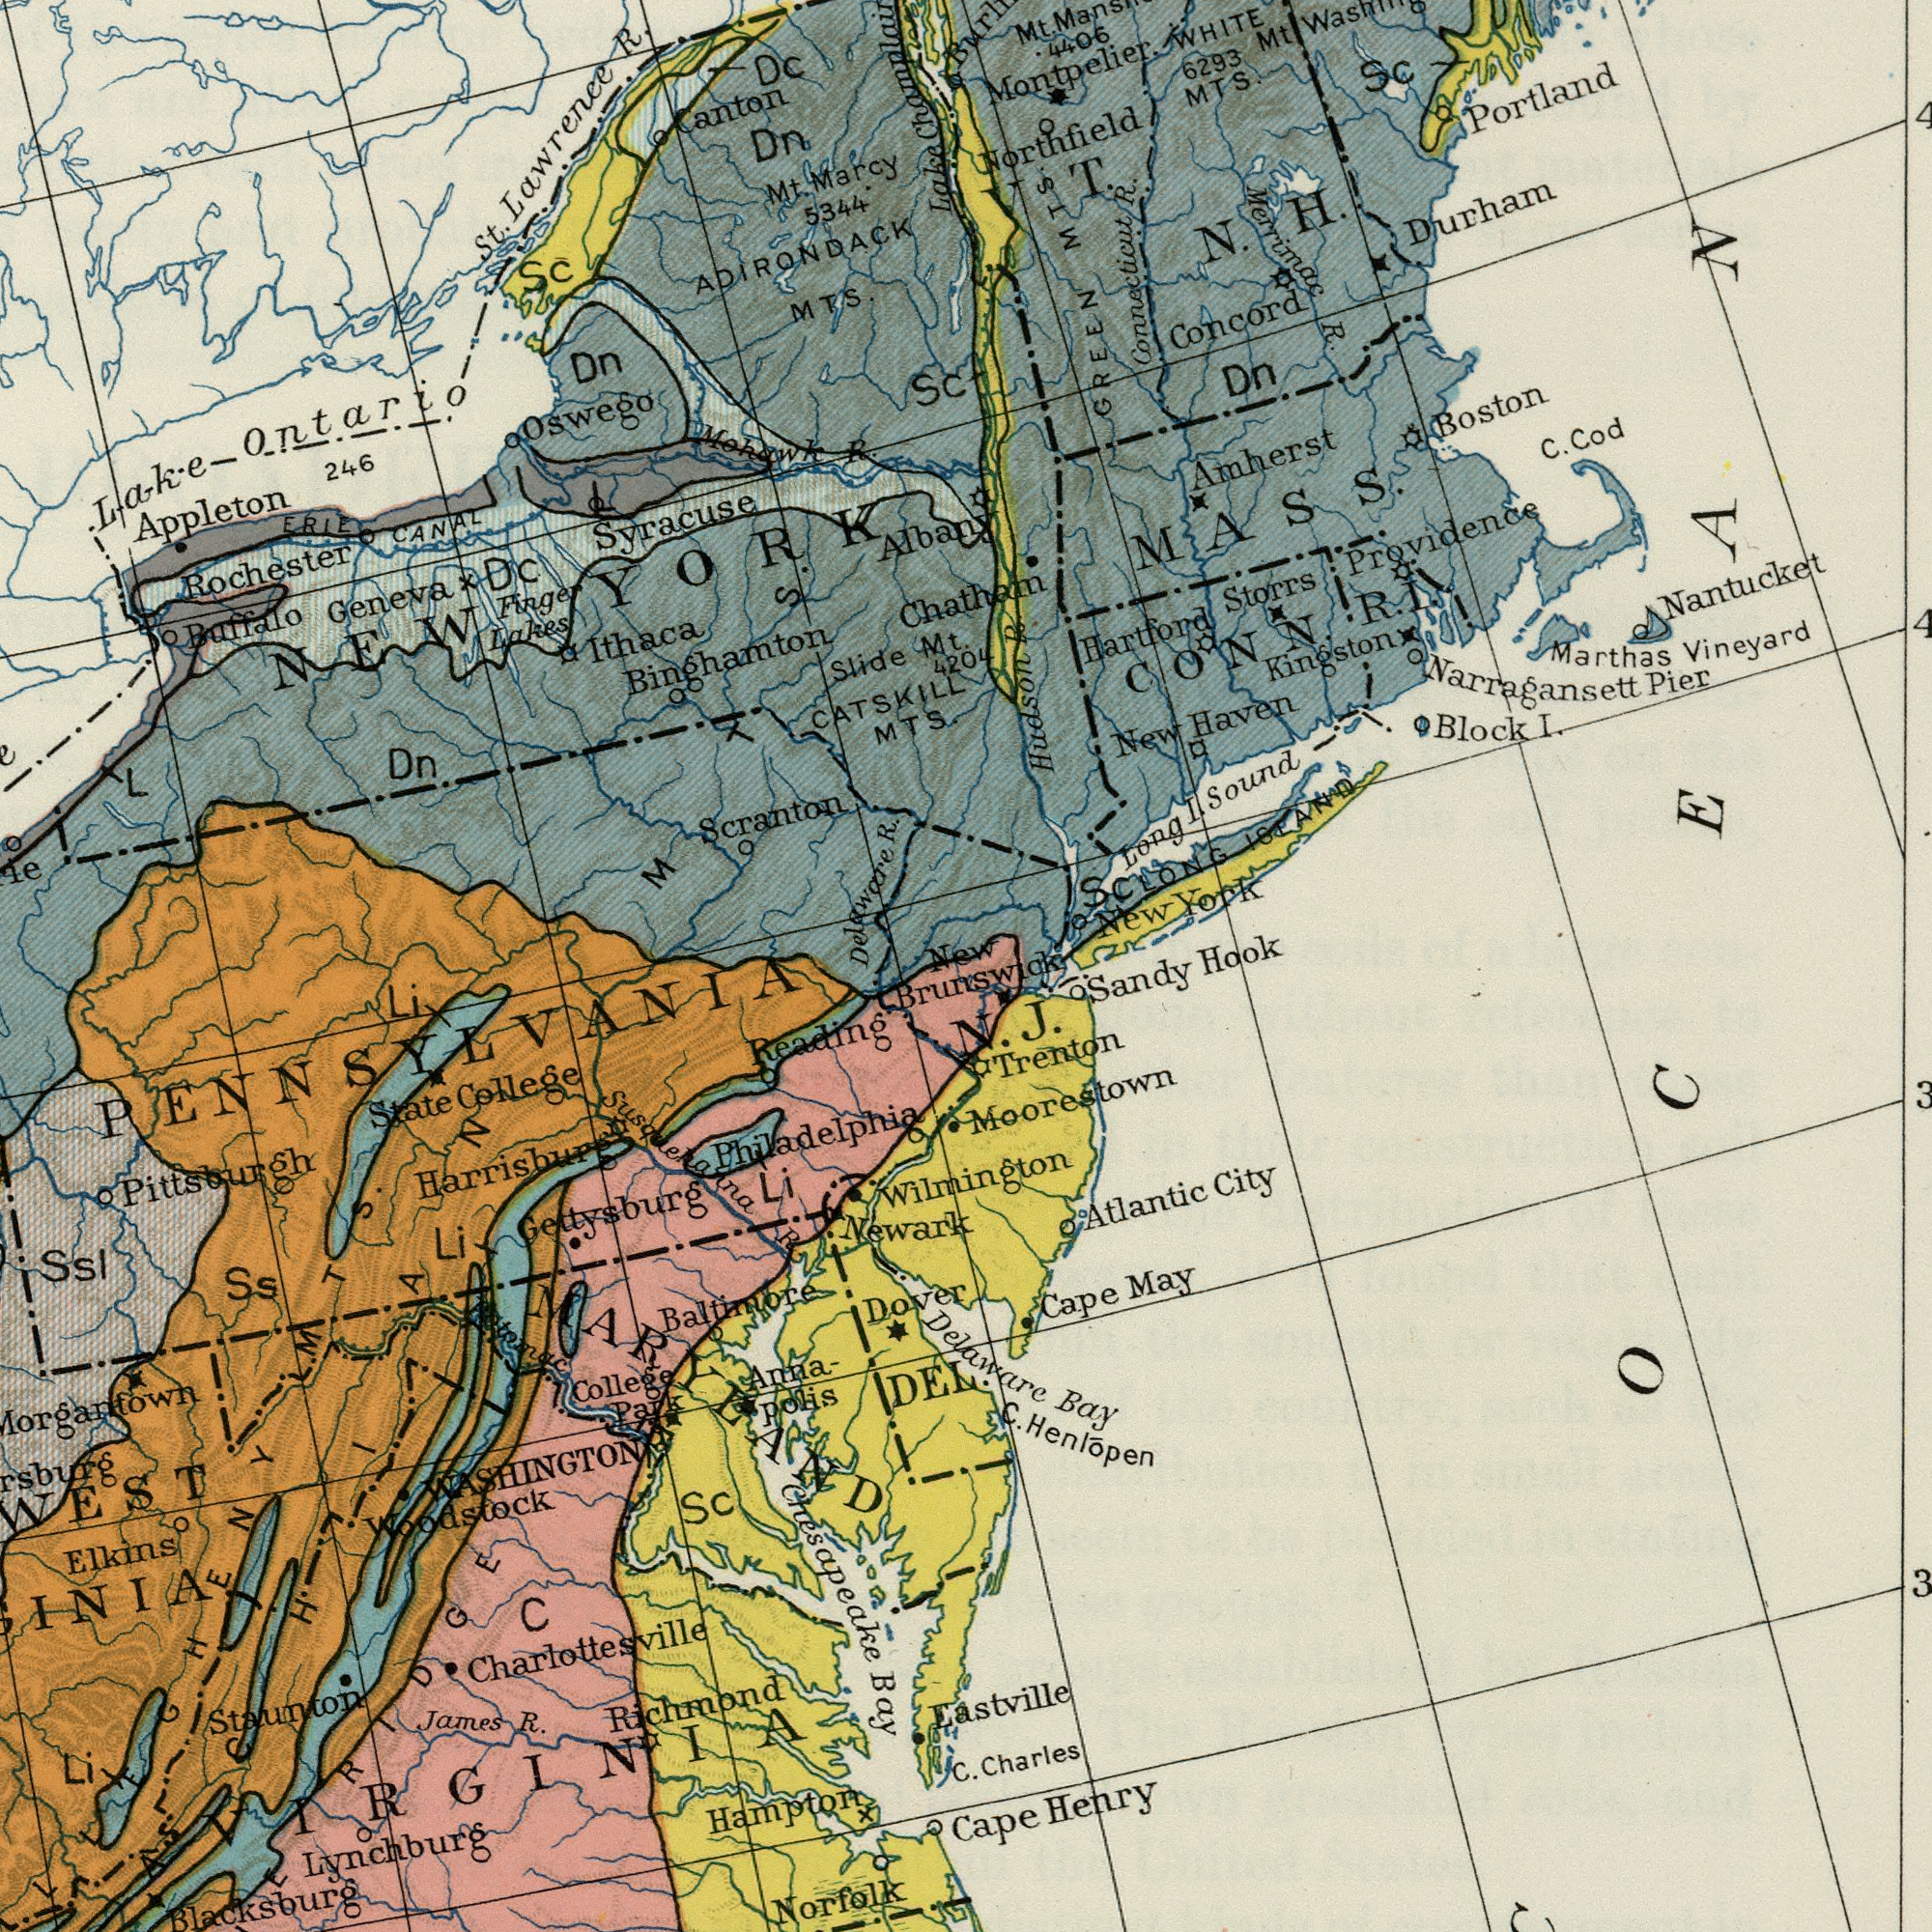What text can you see in the bottom-right section? Brunswick Sandy DEL. Trenton Delaware Bay C. Charles Atlantic City Cape May Eastville Cape Henry C. Henlõpen Moorestown Wilmington N. J. What text is shown in the top-right quadrant? Mt. Lake Albany Sc 4204 New Amherst V T. N. H. New York Montpelier. Portland LONG ISLAND Durham Nantucket New Haven Northfield MTS. Hartford WHITE Connecticut R. Marthas Vineyard GREEN MTS. Hook Merrimac R. Narragansett Pier C. Cod Block I. Dn Kingston 6293 Boston Concord 4406 Sc Long I. Sound Mt. Storrs Chatham Providence CONN. Mt. Washing R. I. Hudson R. MASS. OCEAN Sc What text is shown in the top-left quadrant? Appleton Syracuse ADIRONDACK MTS. Rochester Scranton St. Lawrence R. Lake Ontario Ithaca 5344 Canton Slide Geneva Mohawk R. Binghamton Mt. Marcy Dn. ERIE CANAL Finger Lakes Buffalo CATSKILL MTS. 246 Champlain Dn Delaware R. Dc Dc. Le Oswego Dn Sc L MTS. NEW YORK What text is visible in the lower-left corner? Lynchburg Elkins Richmond Hampton Ssl Staunton Newark James R. Norfolk State College Sc Chesapeake Bay Gettysburg Charlottesville Dover C Li Woodstock Ss Anna- polis Blacksburg Li Baltimore MARYLAND College Park Reading Li Philadelphia Morgantown Li Susquehanna R. Harrisburg WASHINGTON Pittsburgh VIRGINIA PENNSYLVANIA ###ERIDGE MTS. ###ACHIAN Protomac 